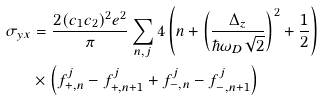Convert formula to latex. <formula><loc_0><loc_0><loc_500><loc_500>\sigma _ { y x } & = \frac { 2 ( c _ { 1 } c _ { 2 } ) ^ { 2 } e ^ { 2 } } { \pi } \sum _ { n , j } 4 \left ( n + \left ( \frac { \Delta _ { z } } { \hbar { \omega } _ { D } \sqrt { 2 } } \right ) ^ { 2 } + \frac { 1 } { 2 } \right ) \\ & \times \left ( f _ { + , n } ^ { j } - f _ { + , n + 1 } ^ { j } + f _ { - , n } ^ { j } - f _ { - , n + 1 } ^ { j } \right )</formula> 